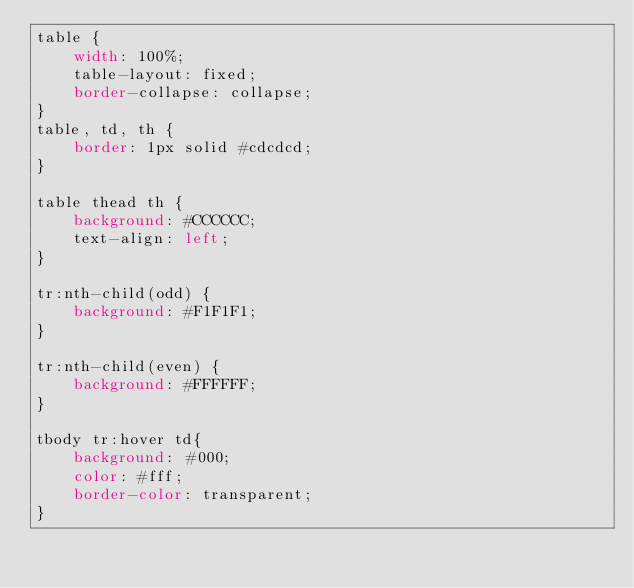Convert code to text. <code><loc_0><loc_0><loc_500><loc_500><_CSS_>table {
	width: 100%;
	table-layout: fixed;
	border-collapse: collapse;
}
table, td, th {
	border: 1px solid #cdcdcd;
}

table thead th {
	background: #CCCCCC;
	text-align: left;
}

tr:nth-child(odd) {
	background: #F1F1F1;
}

tr:nth-child(even) {
	background: #FFFFFF;
}

tbody tr:hover td{
	background: #000;
	color: #fff;
	border-color: transparent;
}</code> 